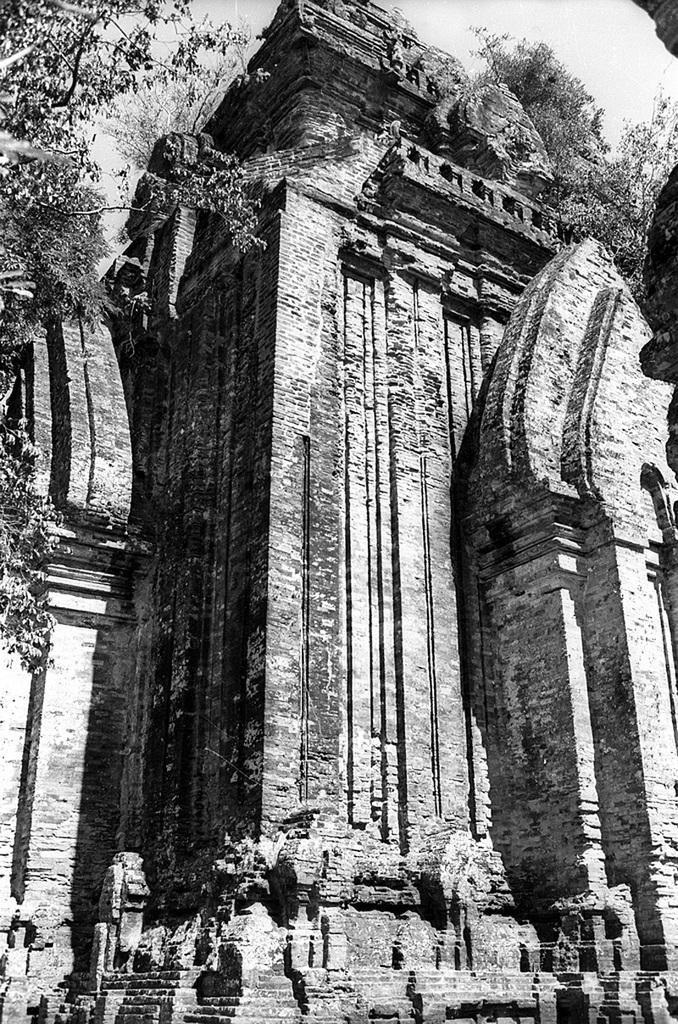What type of structure is present in the image? There is a building in the image. What can be seen in the background of the image? There are trees and the sky visible in the background of the image. What is the color scheme of the image? The image is in black and white. How does the wind affect the throat of the building in the image? There is no wind or throat present in the image, as it features a building, trees, and the sky in a black and white color scheme. 